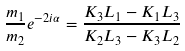<formula> <loc_0><loc_0><loc_500><loc_500>\frac { m _ { 1 } } { m _ { 2 } } e ^ { - 2 i \alpha } = \frac { K _ { 3 } L _ { 1 } - K _ { 1 } L _ { 3 } } { K _ { 2 } L _ { 3 } - K _ { 3 } L _ { 2 } }</formula> 